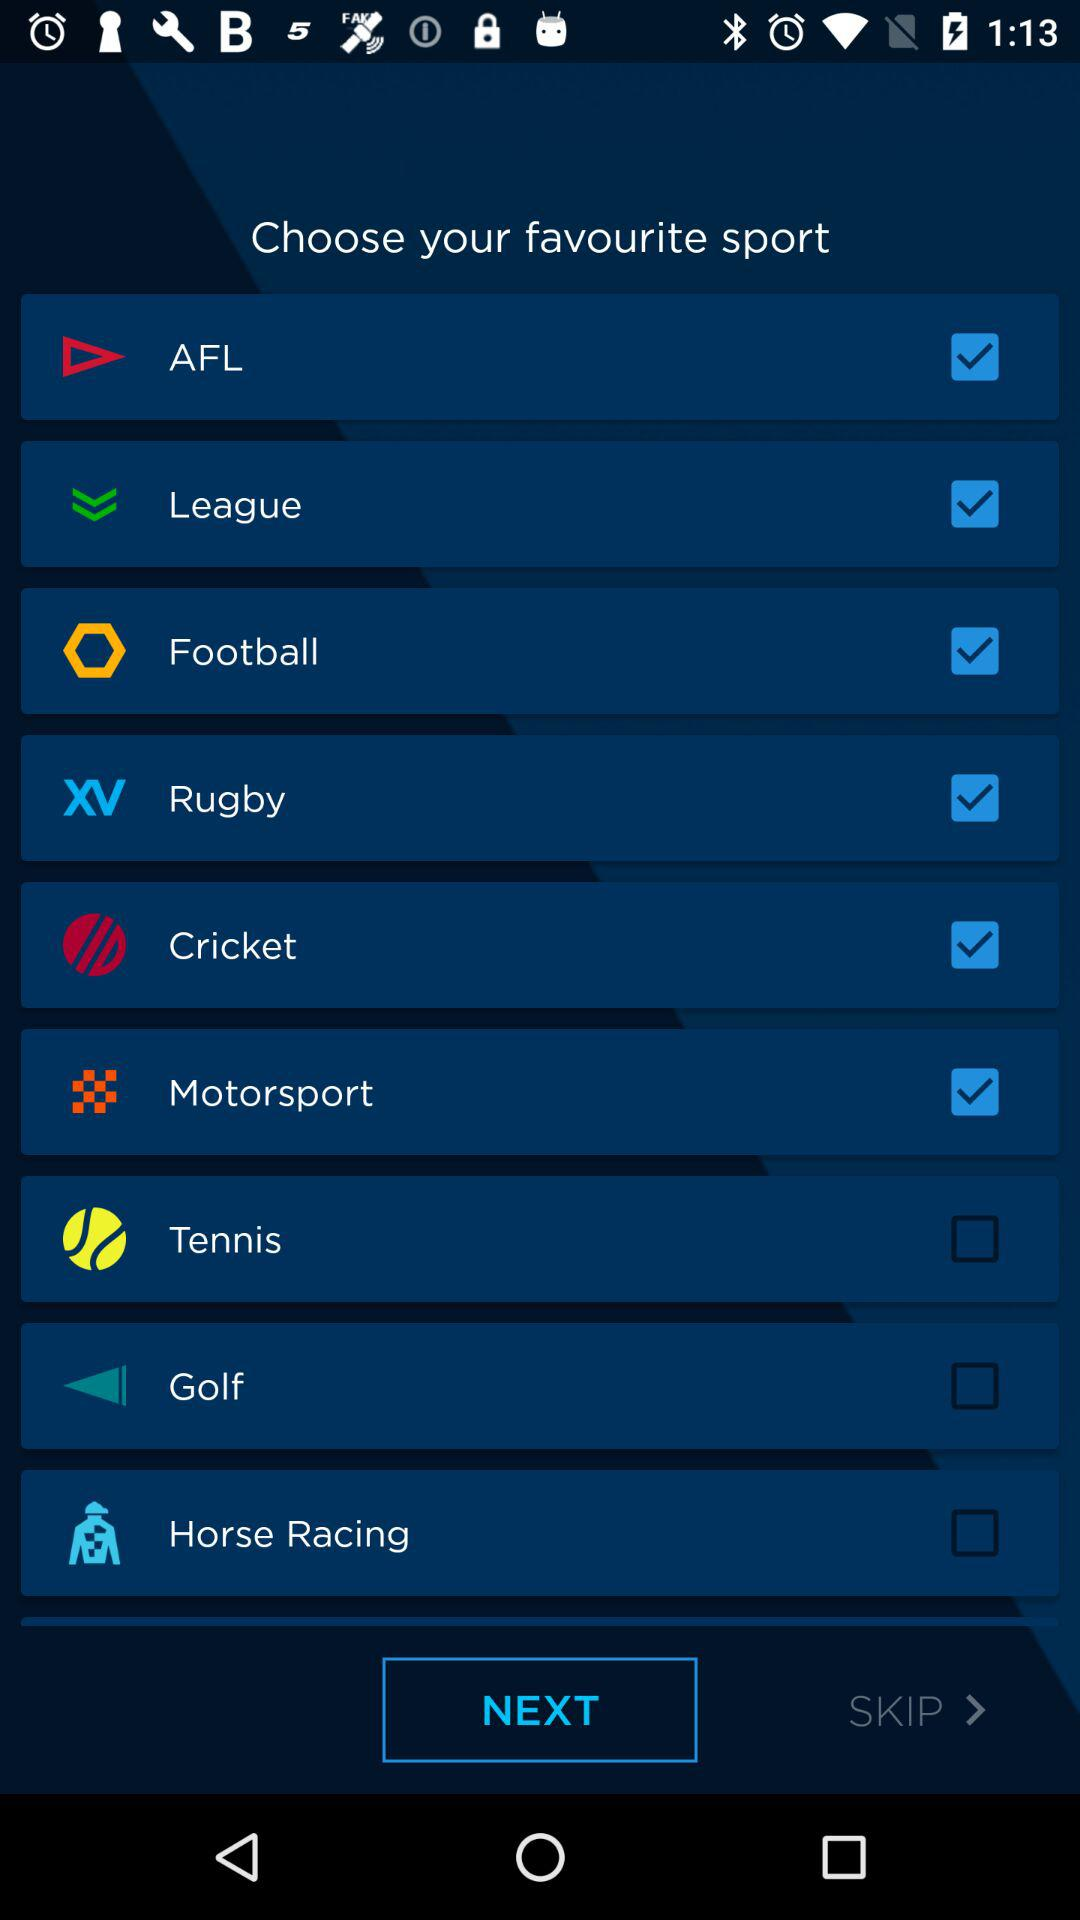Which options are unchecked? The unchecked options are "Tennis", "Golf" and "Horse Racing". 